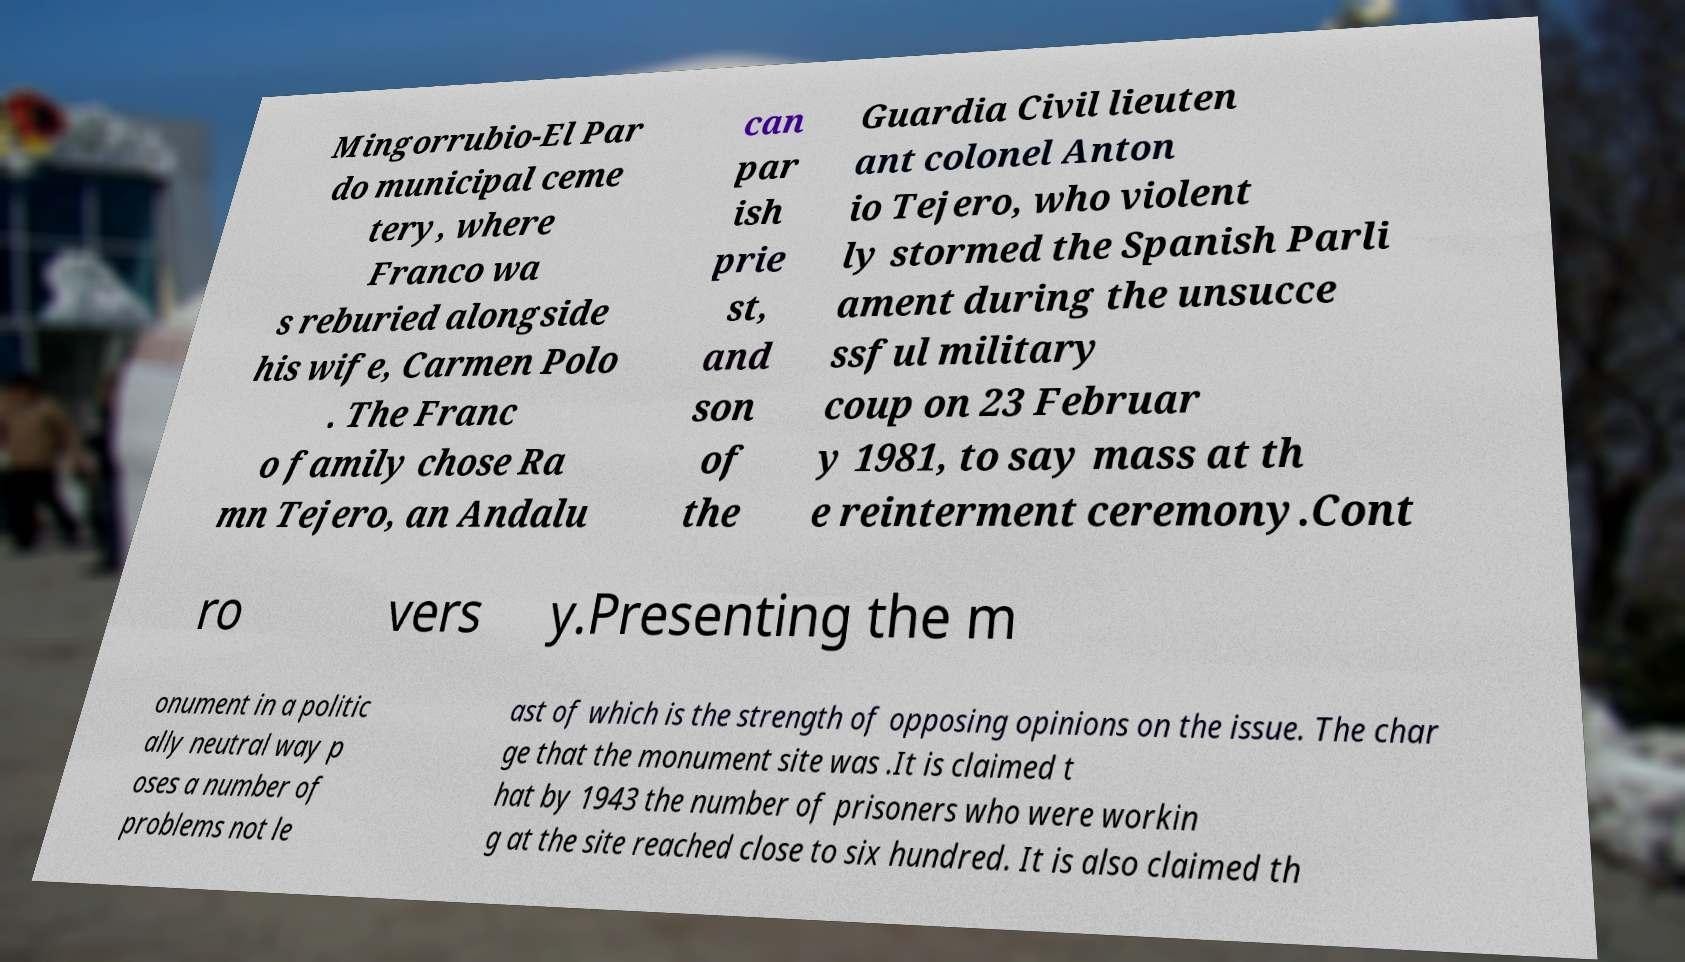What messages or text are displayed in this image? I need them in a readable, typed format. Mingorrubio-El Par do municipal ceme tery, where Franco wa s reburied alongside his wife, Carmen Polo . The Franc o family chose Ra mn Tejero, an Andalu can par ish prie st, and son of the Guardia Civil lieuten ant colonel Anton io Tejero, who violent ly stormed the Spanish Parli ament during the unsucce ssful military coup on 23 Februar y 1981, to say mass at th e reinterment ceremony.Cont ro vers y.Presenting the m onument in a politic ally neutral way p oses a number of problems not le ast of which is the strength of opposing opinions on the issue. The char ge that the monument site was .It is claimed t hat by 1943 the number of prisoners who were workin g at the site reached close to six hundred. It is also claimed th 